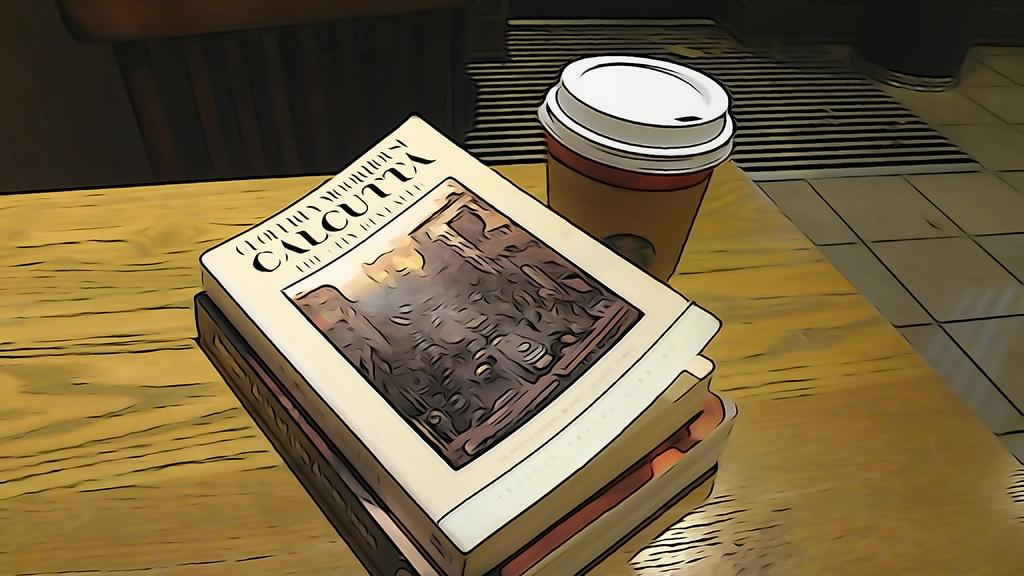<image>
Share a concise interpretation of the image provided. The book shown is about the city of Calcutta in India. 